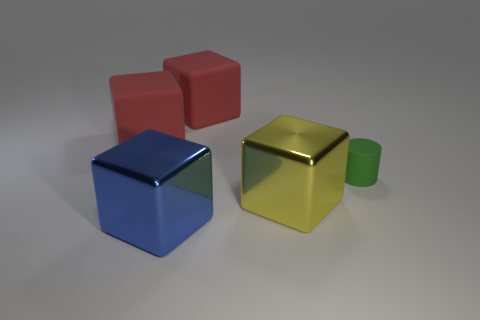Add 1 big yellow objects. How many objects exist? 6 Subtract all cylinders. How many objects are left? 4 Subtract all cylinders. Subtract all big metal objects. How many objects are left? 2 Add 1 rubber cylinders. How many rubber cylinders are left? 2 Add 5 matte blocks. How many matte blocks exist? 7 Subtract 1 red blocks. How many objects are left? 4 